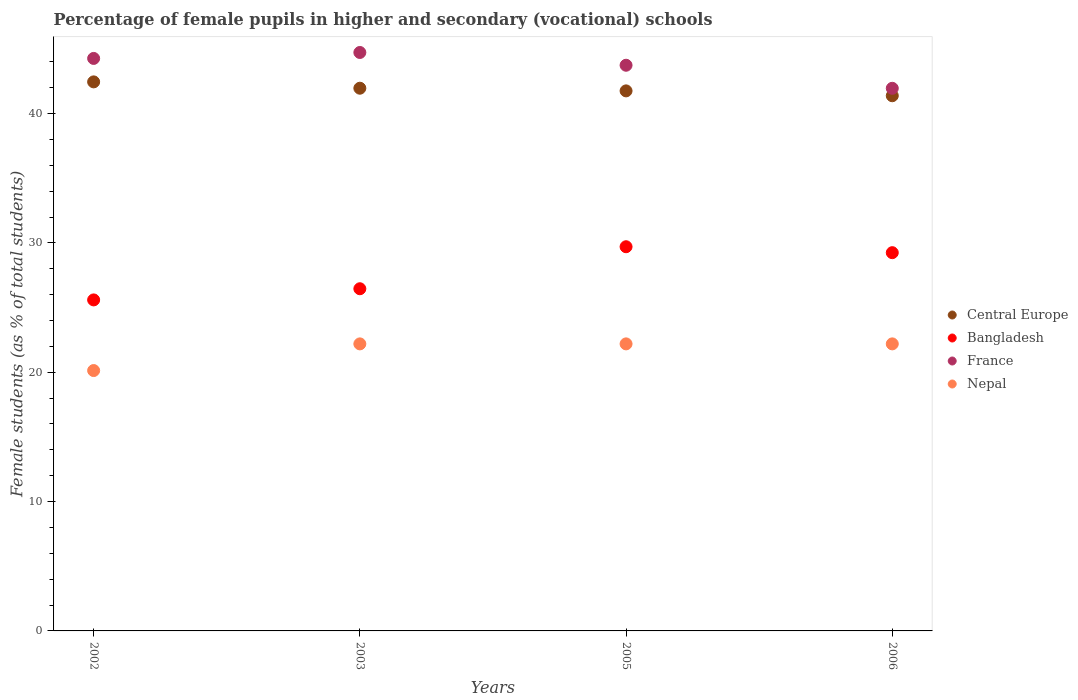What is the percentage of female pupils in higher and secondary schools in Central Europe in 2003?
Offer a very short reply. 41.96. Across all years, what is the maximum percentage of female pupils in higher and secondary schools in Central Europe?
Offer a very short reply. 42.45. Across all years, what is the minimum percentage of female pupils in higher and secondary schools in Bangladesh?
Your response must be concise. 25.59. What is the total percentage of female pupils in higher and secondary schools in Central Europe in the graph?
Provide a succinct answer. 167.54. What is the difference between the percentage of female pupils in higher and secondary schools in Nepal in 2002 and that in 2006?
Ensure brevity in your answer.  -2.06. What is the difference between the percentage of female pupils in higher and secondary schools in Nepal in 2006 and the percentage of female pupils in higher and secondary schools in France in 2002?
Offer a terse response. -22.07. What is the average percentage of female pupils in higher and secondary schools in Bangladesh per year?
Offer a very short reply. 27.75. In the year 2003, what is the difference between the percentage of female pupils in higher and secondary schools in France and percentage of female pupils in higher and secondary schools in Nepal?
Your answer should be compact. 22.53. In how many years, is the percentage of female pupils in higher and secondary schools in France greater than 16 %?
Provide a short and direct response. 4. What is the ratio of the percentage of female pupils in higher and secondary schools in Central Europe in 2002 to that in 2005?
Ensure brevity in your answer.  1.02. Is the percentage of female pupils in higher and secondary schools in Bangladesh in 2003 less than that in 2005?
Provide a short and direct response. Yes. What is the difference between the highest and the second highest percentage of female pupils in higher and secondary schools in Nepal?
Your answer should be very brief. 0. What is the difference between the highest and the lowest percentage of female pupils in higher and secondary schools in France?
Keep it short and to the point. 2.77. Is it the case that in every year, the sum of the percentage of female pupils in higher and secondary schools in Central Europe and percentage of female pupils in higher and secondary schools in Bangladesh  is greater than the sum of percentage of female pupils in higher and secondary schools in Nepal and percentage of female pupils in higher and secondary schools in France?
Your answer should be compact. Yes. Is it the case that in every year, the sum of the percentage of female pupils in higher and secondary schools in France and percentage of female pupils in higher and secondary schools in Central Europe  is greater than the percentage of female pupils in higher and secondary schools in Nepal?
Provide a short and direct response. Yes. Is the percentage of female pupils in higher and secondary schools in Nepal strictly greater than the percentage of female pupils in higher and secondary schools in Bangladesh over the years?
Ensure brevity in your answer.  No. Are the values on the major ticks of Y-axis written in scientific E-notation?
Make the answer very short. No. How are the legend labels stacked?
Keep it short and to the point. Vertical. What is the title of the graph?
Offer a very short reply. Percentage of female pupils in higher and secondary (vocational) schools. Does "Malawi" appear as one of the legend labels in the graph?
Provide a succinct answer. No. What is the label or title of the X-axis?
Make the answer very short. Years. What is the label or title of the Y-axis?
Offer a very short reply. Female students (as % of total students). What is the Female students (as % of total students) in Central Europe in 2002?
Your answer should be compact. 42.45. What is the Female students (as % of total students) in Bangladesh in 2002?
Offer a very short reply. 25.59. What is the Female students (as % of total students) of France in 2002?
Your response must be concise. 44.26. What is the Female students (as % of total students) in Nepal in 2002?
Offer a terse response. 20.13. What is the Female students (as % of total students) of Central Europe in 2003?
Give a very brief answer. 41.96. What is the Female students (as % of total students) in Bangladesh in 2003?
Ensure brevity in your answer.  26.46. What is the Female students (as % of total students) in France in 2003?
Your answer should be compact. 44.72. What is the Female students (as % of total students) of Nepal in 2003?
Provide a succinct answer. 22.19. What is the Female students (as % of total students) in Central Europe in 2005?
Your answer should be very brief. 41.75. What is the Female students (as % of total students) of Bangladesh in 2005?
Make the answer very short. 29.7. What is the Female students (as % of total students) in France in 2005?
Offer a very short reply. 43.73. What is the Female students (as % of total students) in Nepal in 2005?
Your response must be concise. 22.19. What is the Female students (as % of total students) in Central Europe in 2006?
Make the answer very short. 41.38. What is the Female students (as % of total students) in Bangladesh in 2006?
Offer a very short reply. 29.24. What is the Female students (as % of total students) of France in 2006?
Offer a very short reply. 41.95. What is the Female students (as % of total students) in Nepal in 2006?
Your answer should be very brief. 22.19. Across all years, what is the maximum Female students (as % of total students) of Central Europe?
Ensure brevity in your answer.  42.45. Across all years, what is the maximum Female students (as % of total students) of Bangladesh?
Keep it short and to the point. 29.7. Across all years, what is the maximum Female students (as % of total students) of France?
Your response must be concise. 44.72. Across all years, what is the maximum Female students (as % of total students) of Nepal?
Provide a short and direct response. 22.19. Across all years, what is the minimum Female students (as % of total students) of Central Europe?
Make the answer very short. 41.38. Across all years, what is the minimum Female students (as % of total students) in Bangladesh?
Give a very brief answer. 25.59. Across all years, what is the minimum Female students (as % of total students) of France?
Ensure brevity in your answer.  41.95. Across all years, what is the minimum Female students (as % of total students) of Nepal?
Offer a terse response. 20.13. What is the total Female students (as % of total students) of Central Europe in the graph?
Offer a terse response. 167.54. What is the total Female students (as % of total students) in Bangladesh in the graph?
Keep it short and to the point. 111. What is the total Female students (as % of total students) of France in the graph?
Provide a short and direct response. 174.67. What is the total Female students (as % of total students) of Nepal in the graph?
Your answer should be very brief. 86.71. What is the difference between the Female students (as % of total students) of Central Europe in 2002 and that in 2003?
Make the answer very short. 0.49. What is the difference between the Female students (as % of total students) of Bangladesh in 2002 and that in 2003?
Offer a very short reply. -0.86. What is the difference between the Female students (as % of total students) in France in 2002 and that in 2003?
Your response must be concise. -0.46. What is the difference between the Female students (as % of total students) in Nepal in 2002 and that in 2003?
Offer a terse response. -2.06. What is the difference between the Female students (as % of total students) in Central Europe in 2002 and that in 2005?
Offer a terse response. 0.7. What is the difference between the Female students (as % of total students) of Bangladesh in 2002 and that in 2005?
Give a very brief answer. -4.11. What is the difference between the Female students (as % of total students) of France in 2002 and that in 2005?
Offer a terse response. 0.53. What is the difference between the Female students (as % of total students) of Nepal in 2002 and that in 2005?
Ensure brevity in your answer.  -2.06. What is the difference between the Female students (as % of total students) of Central Europe in 2002 and that in 2006?
Keep it short and to the point. 1.07. What is the difference between the Female students (as % of total students) in Bangladesh in 2002 and that in 2006?
Provide a succinct answer. -3.65. What is the difference between the Female students (as % of total students) of France in 2002 and that in 2006?
Provide a succinct answer. 2.31. What is the difference between the Female students (as % of total students) in Nepal in 2002 and that in 2006?
Your answer should be very brief. -2.06. What is the difference between the Female students (as % of total students) of Central Europe in 2003 and that in 2005?
Give a very brief answer. 0.21. What is the difference between the Female students (as % of total students) in Bangladesh in 2003 and that in 2005?
Your answer should be compact. -3.25. What is the difference between the Female students (as % of total students) of France in 2003 and that in 2005?
Make the answer very short. 0.99. What is the difference between the Female students (as % of total students) in Nepal in 2003 and that in 2005?
Offer a very short reply. 0. What is the difference between the Female students (as % of total students) of Central Europe in 2003 and that in 2006?
Offer a very short reply. 0.58. What is the difference between the Female students (as % of total students) of Bangladesh in 2003 and that in 2006?
Provide a short and direct response. -2.79. What is the difference between the Female students (as % of total students) of France in 2003 and that in 2006?
Make the answer very short. 2.77. What is the difference between the Female students (as % of total students) of Nepal in 2003 and that in 2006?
Make the answer very short. -0. What is the difference between the Female students (as % of total students) in Central Europe in 2005 and that in 2006?
Provide a succinct answer. 0.38. What is the difference between the Female students (as % of total students) in Bangladesh in 2005 and that in 2006?
Your answer should be compact. 0.46. What is the difference between the Female students (as % of total students) of France in 2005 and that in 2006?
Provide a succinct answer. 1.78. What is the difference between the Female students (as % of total students) in Nepal in 2005 and that in 2006?
Offer a very short reply. -0. What is the difference between the Female students (as % of total students) of Central Europe in 2002 and the Female students (as % of total students) of Bangladesh in 2003?
Give a very brief answer. 15.99. What is the difference between the Female students (as % of total students) in Central Europe in 2002 and the Female students (as % of total students) in France in 2003?
Offer a terse response. -2.27. What is the difference between the Female students (as % of total students) in Central Europe in 2002 and the Female students (as % of total students) in Nepal in 2003?
Ensure brevity in your answer.  20.26. What is the difference between the Female students (as % of total students) of Bangladesh in 2002 and the Female students (as % of total students) of France in 2003?
Provide a short and direct response. -19.13. What is the difference between the Female students (as % of total students) of Bangladesh in 2002 and the Female students (as % of total students) of Nepal in 2003?
Ensure brevity in your answer.  3.4. What is the difference between the Female students (as % of total students) in France in 2002 and the Female students (as % of total students) in Nepal in 2003?
Make the answer very short. 22.07. What is the difference between the Female students (as % of total students) of Central Europe in 2002 and the Female students (as % of total students) of Bangladesh in 2005?
Offer a terse response. 12.75. What is the difference between the Female students (as % of total students) in Central Europe in 2002 and the Female students (as % of total students) in France in 2005?
Your answer should be very brief. -1.29. What is the difference between the Female students (as % of total students) in Central Europe in 2002 and the Female students (as % of total students) in Nepal in 2005?
Your response must be concise. 20.26. What is the difference between the Female students (as % of total students) in Bangladesh in 2002 and the Female students (as % of total students) in France in 2005?
Keep it short and to the point. -18.14. What is the difference between the Female students (as % of total students) in Bangladesh in 2002 and the Female students (as % of total students) in Nepal in 2005?
Offer a very short reply. 3.4. What is the difference between the Female students (as % of total students) of France in 2002 and the Female students (as % of total students) of Nepal in 2005?
Give a very brief answer. 22.07. What is the difference between the Female students (as % of total students) of Central Europe in 2002 and the Female students (as % of total students) of Bangladesh in 2006?
Ensure brevity in your answer.  13.21. What is the difference between the Female students (as % of total students) in Central Europe in 2002 and the Female students (as % of total students) in France in 2006?
Keep it short and to the point. 0.5. What is the difference between the Female students (as % of total students) of Central Europe in 2002 and the Female students (as % of total students) of Nepal in 2006?
Your response must be concise. 20.26. What is the difference between the Female students (as % of total students) in Bangladesh in 2002 and the Female students (as % of total students) in France in 2006?
Your answer should be compact. -16.36. What is the difference between the Female students (as % of total students) in Bangladesh in 2002 and the Female students (as % of total students) in Nepal in 2006?
Give a very brief answer. 3.4. What is the difference between the Female students (as % of total students) of France in 2002 and the Female students (as % of total students) of Nepal in 2006?
Your answer should be very brief. 22.07. What is the difference between the Female students (as % of total students) in Central Europe in 2003 and the Female students (as % of total students) in Bangladesh in 2005?
Offer a very short reply. 12.26. What is the difference between the Female students (as % of total students) in Central Europe in 2003 and the Female students (as % of total students) in France in 2005?
Make the answer very short. -1.78. What is the difference between the Female students (as % of total students) in Central Europe in 2003 and the Female students (as % of total students) in Nepal in 2005?
Provide a succinct answer. 19.77. What is the difference between the Female students (as % of total students) in Bangladesh in 2003 and the Female students (as % of total students) in France in 2005?
Make the answer very short. -17.28. What is the difference between the Female students (as % of total students) in Bangladesh in 2003 and the Female students (as % of total students) in Nepal in 2005?
Your answer should be compact. 4.26. What is the difference between the Female students (as % of total students) of France in 2003 and the Female students (as % of total students) of Nepal in 2005?
Give a very brief answer. 22.53. What is the difference between the Female students (as % of total students) of Central Europe in 2003 and the Female students (as % of total students) of Bangladesh in 2006?
Give a very brief answer. 12.71. What is the difference between the Female students (as % of total students) of Central Europe in 2003 and the Female students (as % of total students) of France in 2006?
Offer a terse response. 0.01. What is the difference between the Female students (as % of total students) in Central Europe in 2003 and the Female students (as % of total students) in Nepal in 2006?
Your response must be concise. 19.77. What is the difference between the Female students (as % of total students) of Bangladesh in 2003 and the Female students (as % of total students) of France in 2006?
Give a very brief answer. -15.5. What is the difference between the Female students (as % of total students) of Bangladesh in 2003 and the Female students (as % of total students) of Nepal in 2006?
Your response must be concise. 4.26. What is the difference between the Female students (as % of total students) in France in 2003 and the Female students (as % of total students) in Nepal in 2006?
Make the answer very short. 22.53. What is the difference between the Female students (as % of total students) of Central Europe in 2005 and the Female students (as % of total students) of Bangladesh in 2006?
Offer a terse response. 12.51. What is the difference between the Female students (as % of total students) of Central Europe in 2005 and the Female students (as % of total students) of France in 2006?
Make the answer very short. -0.2. What is the difference between the Female students (as % of total students) in Central Europe in 2005 and the Female students (as % of total students) in Nepal in 2006?
Offer a terse response. 19.56. What is the difference between the Female students (as % of total students) in Bangladesh in 2005 and the Female students (as % of total students) in France in 2006?
Offer a terse response. -12.25. What is the difference between the Female students (as % of total students) of Bangladesh in 2005 and the Female students (as % of total students) of Nepal in 2006?
Offer a very short reply. 7.51. What is the difference between the Female students (as % of total students) of France in 2005 and the Female students (as % of total students) of Nepal in 2006?
Your response must be concise. 21.54. What is the average Female students (as % of total students) in Central Europe per year?
Provide a short and direct response. 41.88. What is the average Female students (as % of total students) in Bangladesh per year?
Offer a terse response. 27.75. What is the average Female students (as % of total students) in France per year?
Provide a succinct answer. 43.67. What is the average Female students (as % of total students) in Nepal per year?
Offer a terse response. 21.68. In the year 2002, what is the difference between the Female students (as % of total students) in Central Europe and Female students (as % of total students) in Bangladesh?
Offer a very short reply. 16.86. In the year 2002, what is the difference between the Female students (as % of total students) in Central Europe and Female students (as % of total students) in France?
Your response must be concise. -1.81. In the year 2002, what is the difference between the Female students (as % of total students) of Central Europe and Female students (as % of total students) of Nepal?
Your response must be concise. 22.32. In the year 2002, what is the difference between the Female students (as % of total students) of Bangladesh and Female students (as % of total students) of France?
Your response must be concise. -18.67. In the year 2002, what is the difference between the Female students (as % of total students) in Bangladesh and Female students (as % of total students) in Nepal?
Ensure brevity in your answer.  5.46. In the year 2002, what is the difference between the Female students (as % of total students) of France and Female students (as % of total students) of Nepal?
Your answer should be very brief. 24.13. In the year 2003, what is the difference between the Female students (as % of total students) in Central Europe and Female students (as % of total students) in Bangladesh?
Keep it short and to the point. 15.5. In the year 2003, what is the difference between the Female students (as % of total students) of Central Europe and Female students (as % of total students) of France?
Offer a terse response. -2.76. In the year 2003, what is the difference between the Female students (as % of total students) of Central Europe and Female students (as % of total students) of Nepal?
Make the answer very short. 19.77. In the year 2003, what is the difference between the Female students (as % of total students) of Bangladesh and Female students (as % of total students) of France?
Your answer should be compact. -18.27. In the year 2003, what is the difference between the Female students (as % of total students) of Bangladesh and Female students (as % of total students) of Nepal?
Provide a succinct answer. 4.26. In the year 2003, what is the difference between the Female students (as % of total students) in France and Female students (as % of total students) in Nepal?
Keep it short and to the point. 22.53. In the year 2005, what is the difference between the Female students (as % of total students) in Central Europe and Female students (as % of total students) in Bangladesh?
Give a very brief answer. 12.05. In the year 2005, what is the difference between the Female students (as % of total students) of Central Europe and Female students (as % of total students) of France?
Offer a terse response. -1.98. In the year 2005, what is the difference between the Female students (as % of total students) of Central Europe and Female students (as % of total students) of Nepal?
Your answer should be very brief. 19.56. In the year 2005, what is the difference between the Female students (as % of total students) of Bangladesh and Female students (as % of total students) of France?
Keep it short and to the point. -14.03. In the year 2005, what is the difference between the Female students (as % of total students) in Bangladesh and Female students (as % of total students) in Nepal?
Make the answer very short. 7.51. In the year 2005, what is the difference between the Female students (as % of total students) of France and Female students (as % of total students) of Nepal?
Ensure brevity in your answer.  21.54. In the year 2006, what is the difference between the Female students (as % of total students) of Central Europe and Female students (as % of total students) of Bangladesh?
Provide a short and direct response. 12.13. In the year 2006, what is the difference between the Female students (as % of total students) of Central Europe and Female students (as % of total students) of France?
Give a very brief answer. -0.58. In the year 2006, what is the difference between the Female students (as % of total students) of Central Europe and Female students (as % of total students) of Nepal?
Ensure brevity in your answer.  19.18. In the year 2006, what is the difference between the Female students (as % of total students) in Bangladesh and Female students (as % of total students) in France?
Ensure brevity in your answer.  -12.71. In the year 2006, what is the difference between the Female students (as % of total students) of Bangladesh and Female students (as % of total students) of Nepal?
Offer a very short reply. 7.05. In the year 2006, what is the difference between the Female students (as % of total students) in France and Female students (as % of total students) in Nepal?
Offer a terse response. 19.76. What is the ratio of the Female students (as % of total students) in Central Europe in 2002 to that in 2003?
Give a very brief answer. 1.01. What is the ratio of the Female students (as % of total students) in Bangladesh in 2002 to that in 2003?
Offer a very short reply. 0.97. What is the ratio of the Female students (as % of total students) in Nepal in 2002 to that in 2003?
Your response must be concise. 0.91. What is the ratio of the Female students (as % of total students) of Central Europe in 2002 to that in 2005?
Your answer should be compact. 1.02. What is the ratio of the Female students (as % of total students) of Bangladesh in 2002 to that in 2005?
Give a very brief answer. 0.86. What is the ratio of the Female students (as % of total students) in France in 2002 to that in 2005?
Offer a very short reply. 1.01. What is the ratio of the Female students (as % of total students) in Nepal in 2002 to that in 2005?
Offer a terse response. 0.91. What is the ratio of the Female students (as % of total students) of Central Europe in 2002 to that in 2006?
Your response must be concise. 1.03. What is the ratio of the Female students (as % of total students) of Bangladesh in 2002 to that in 2006?
Provide a succinct answer. 0.88. What is the ratio of the Female students (as % of total students) in France in 2002 to that in 2006?
Ensure brevity in your answer.  1.06. What is the ratio of the Female students (as % of total students) of Nepal in 2002 to that in 2006?
Offer a very short reply. 0.91. What is the ratio of the Female students (as % of total students) in Central Europe in 2003 to that in 2005?
Your answer should be very brief. 1. What is the ratio of the Female students (as % of total students) of Bangladesh in 2003 to that in 2005?
Offer a very short reply. 0.89. What is the ratio of the Female students (as % of total students) in France in 2003 to that in 2005?
Keep it short and to the point. 1.02. What is the ratio of the Female students (as % of total students) of Central Europe in 2003 to that in 2006?
Offer a very short reply. 1.01. What is the ratio of the Female students (as % of total students) in Bangladesh in 2003 to that in 2006?
Give a very brief answer. 0.9. What is the ratio of the Female students (as % of total students) in France in 2003 to that in 2006?
Keep it short and to the point. 1.07. What is the ratio of the Female students (as % of total students) in Nepal in 2003 to that in 2006?
Provide a short and direct response. 1. What is the ratio of the Female students (as % of total students) in Central Europe in 2005 to that in 2006?
Give a very brief answer. 1.01. What is the ratio of the Female students (as % of total students) of Bangladesh in 2005 to that in 2006?
Give a very brief answer. 1.02. What is the ratio of the Female students (as % of total students) of France in 2005 to that in 2006?
Offer a very short reply. 1.04. What is the difference between the highest and the second highest Female students (as % of total students) of Central Europe?
Give a very brief answer. 0.49. What is the difference between the highest and the second highest Female students (as % of total students) of Bangladesh?
Provide a succinct answer. 0.46. What is the difference between the highest and the second highest Female students (as % of total students) of France?
Keep it short and to the point. 0.46. What is the difference between the highest and the second highest Female students (as % of total students) in Nepal?
Your response must be concise. 0. What is the difference between the highest and the lowest Female students (as % of total students) of Central Europe?
Make the answer very short. 1.07. What is the difference between the highest and the lowest Female students (as % of total students) of Bangladesh?
Your answer should be very brief. 4.11. What is the difference between the highest and the lowest Female students (as % of total students) in France?
Provide a short and direct response. 2.77. What is the difference between the highest and the lowest Female students (as % of total students) in Nepal?
Your response must be concise. 2.06. 